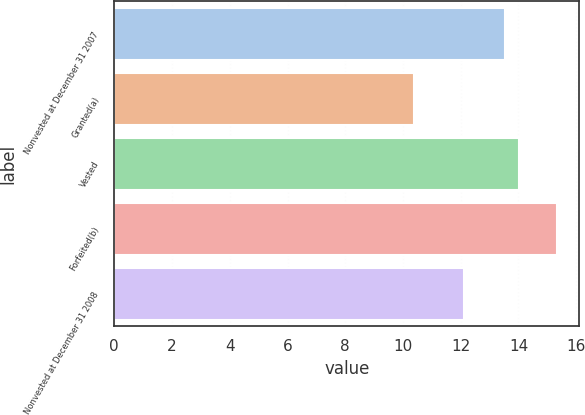Convert chart. <chart><loc_0><loc_0><loc_500><loc_500><bar_chart><fcel>Nonvested at December 31 2007<fcel>Granted(a)<fcel>Vested<fcel>Forfeited(b)<fcel>Nonvested at December 31 2008<nl><fcel>13.52<fcel>10.38<fcel>14.02<fcel>15.34<fcel>12.1<nl></chart> 